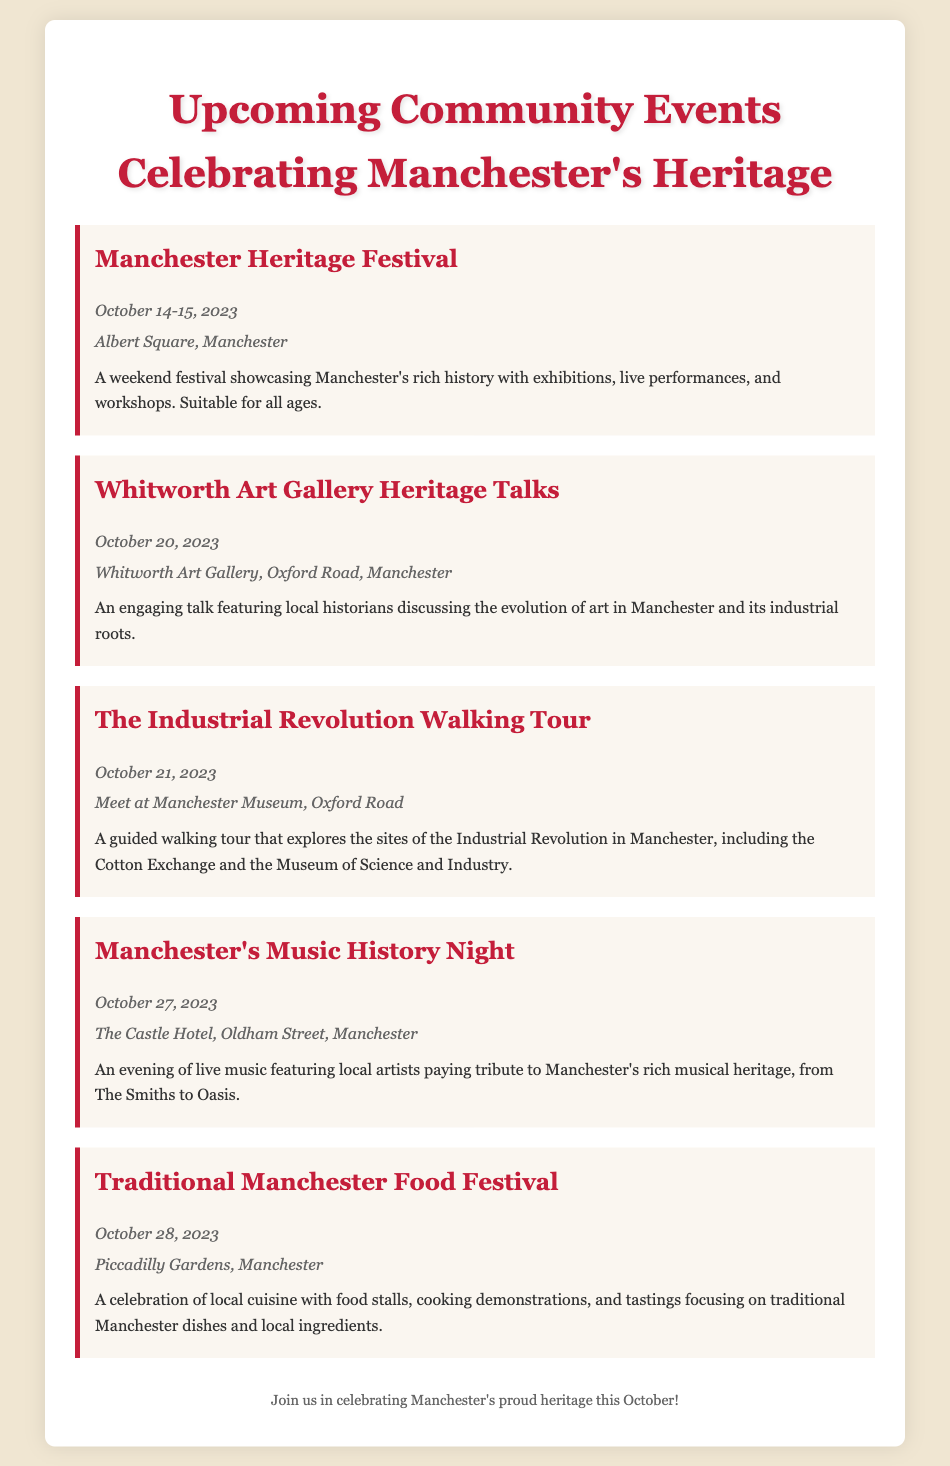what are the dates for the Manchester Heritage Festival? The dates for the Manchester Heritage Festival are specified as October 14-15, 2023.
Answer: October 14-15, 2023 where is the Whitworth Art Gallery Heritage Talks event located? The location of the Whitworth Art Gallery Heritage Talks event is mentioned as Whitworth Art Gallery, Oxford Road, Manchester.
Answer: Whitworth Art Gallery, Oxford Road, Manchester what type of event is happening on October 28, 2023? The event on October 28, 2023 is identified as the Traditional Manchester Food Festival, which focuses on local cuisine.
Answer: Traditional Manchester Food Festival how many events are scheduled for October 2023? There are a total of five events listed in the document for October 2023.
Answer: Five which event highlights Manchester's musical heritage? The event that highlights Manchester's musical heritage is called Manchester's Music History Night.
Answer: Manchester's Music History Night what is the description of the Industrial Revolution Walking Tour? The description of the Industrial Revolution Walking Tour includes exploring sites related to the Industrial Revolution, such as the Cotton Exchange and the Museum of Science and Industry.
Answer: A guided walking tour that explores the sites of the Industrial Revolution in Manchester, including the Cotton Exchange and the Museum of Science and Industry what community event takes place in Albert Square? The community event that takes place in Albert Square is the Manchester Heritage Festival.
Answer: Manchester Heritage Festival which event is held on the same day as the Industrial Revolution Walking Tour? The event held on the same day as the Industrial Revolution Walking Tour is the Whitworth Art Gallery Heritage Talks.
Answer: Whitworth Art Gallery Heritage Talks 